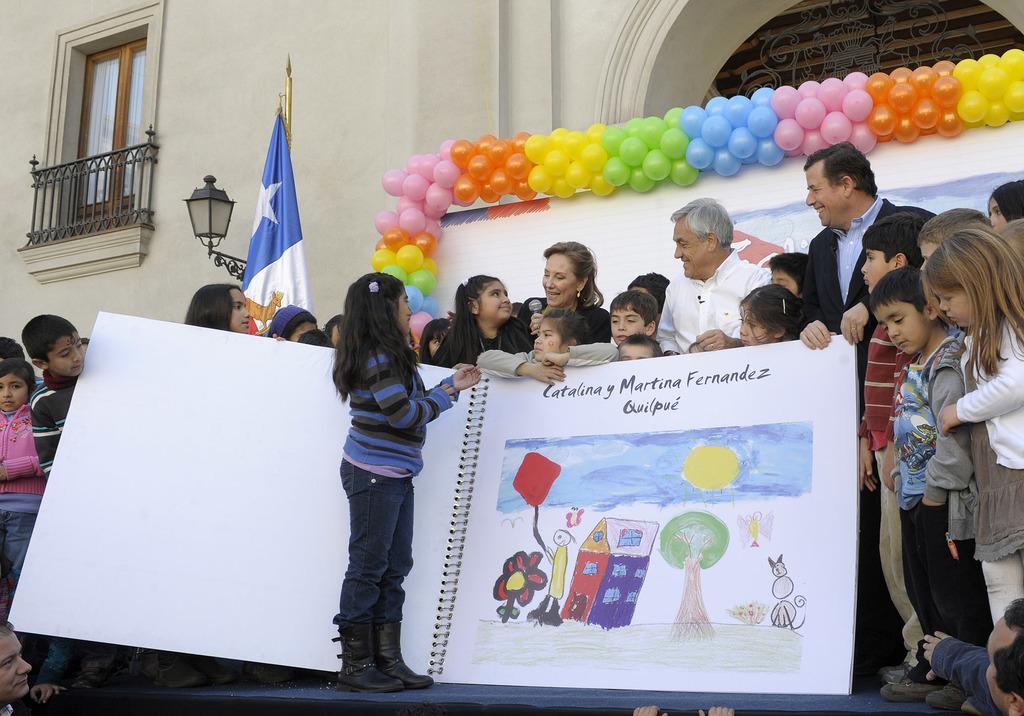Describe this image in one or two sentences. In this image I can see at the bottom there is a painting book, in the middle a group of people are standing, on the right side there are balloons. On the left side there is a flag beside it there is a lamp and there is a glass window. 